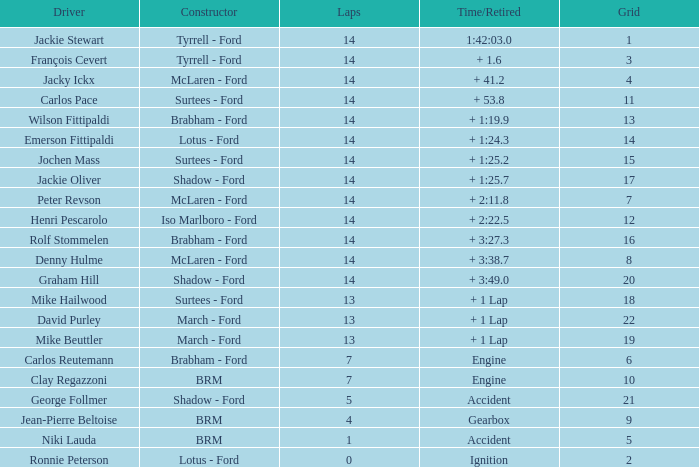For a grid bigger than 16 and a time/retired of +3:27.3, what is the lowest lap total? None. 